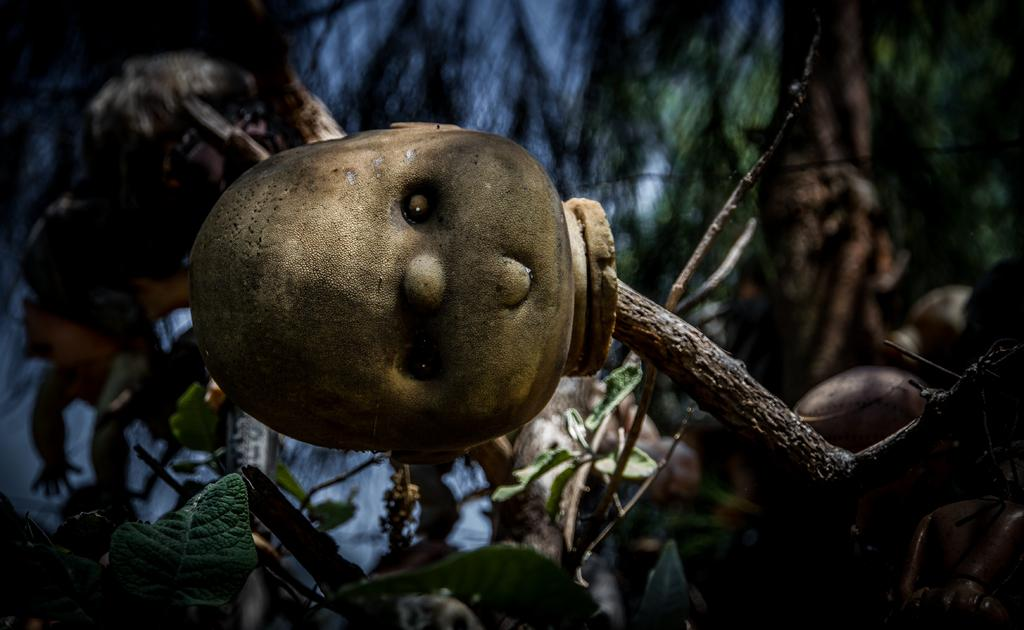What type of natural elements are present in the image? There are branches with leaves in the image. What type of object is featured in the foreground of the image? The head of a toy is in the foreground of the image. How would you describe the background of the image? The background of the image is blurry. What else can be seen in the background of the image? There are toys or toy-like objects visible in the background of the image. What color is the bead that is hanging from the bucket in the image? There is no bucket or bead present in the image. How does the front of the image differ from the back? The image does not have a front or back, as it is a two-dimensional representation. 